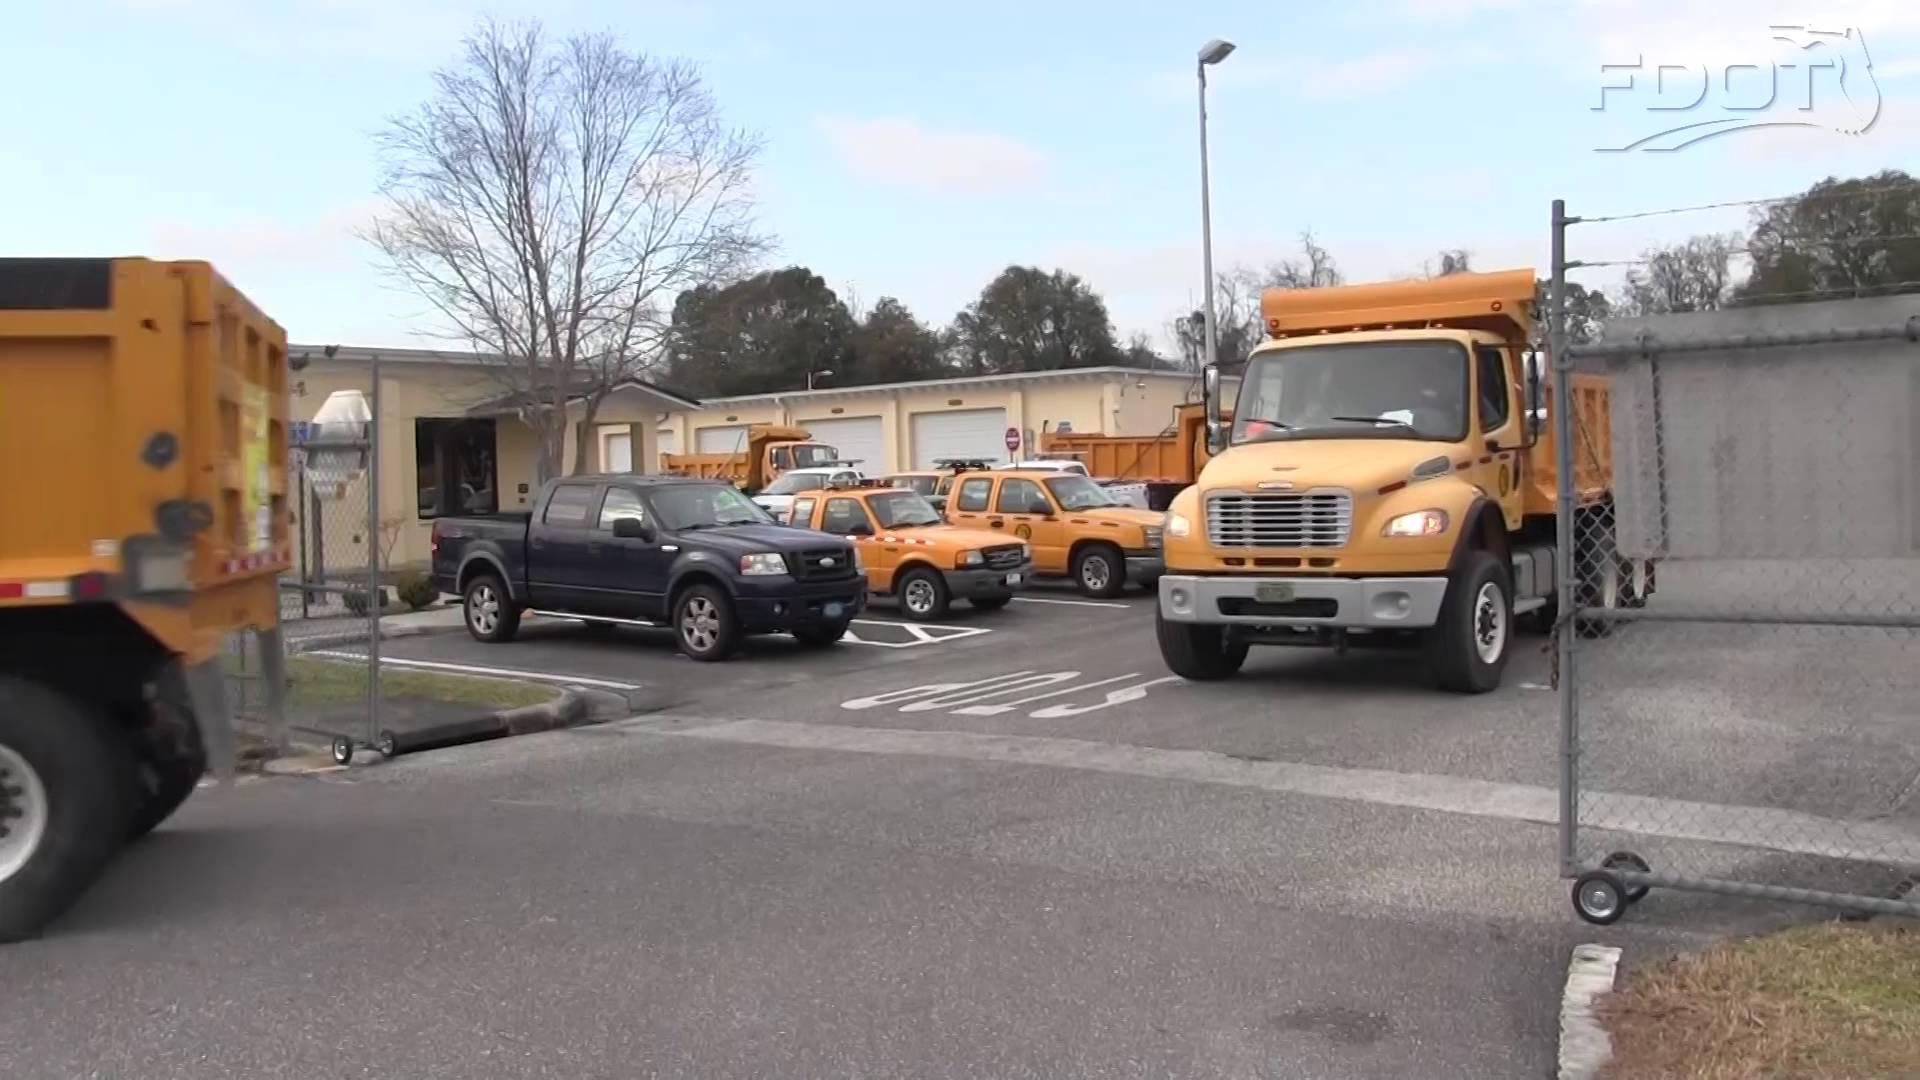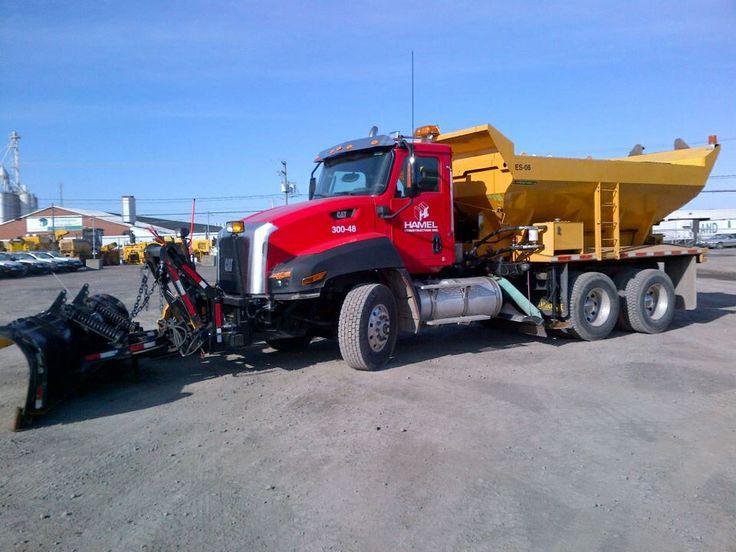The first image is the image on the left, the second image is the image on the right. Considering the images on both sides, is "There are two bulldozers both facing left." valid? Answer yes or no. No. The first image is the image on the left, the second image is the image on the right. Given the left and right images, does the statement "An image shows multiple trucks with golden-yellow cabs and beds parked in a dry paved area." hold true? Answer yes or no. Yes. 